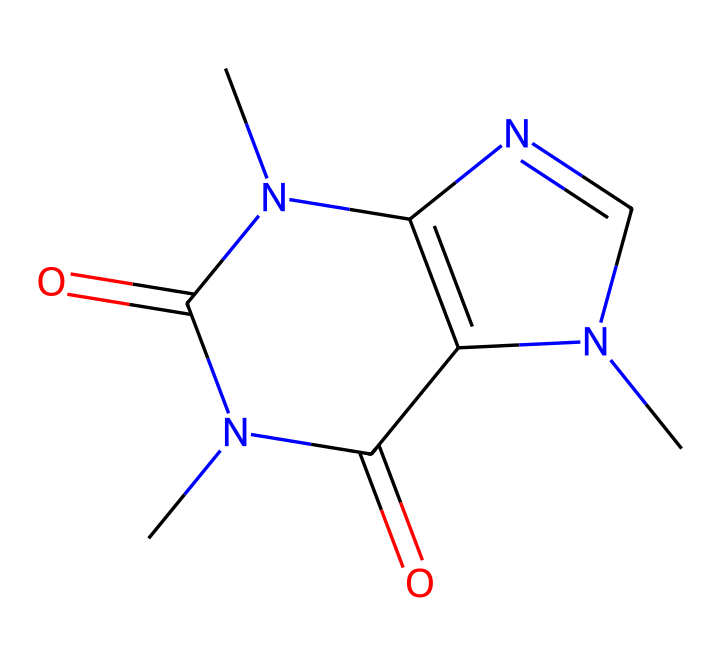how many nitrogen atoms are present in the structure? The SMILES representation indicates there are three nitrogen atoms (N), which can be identified by counting the 'N' symbols.
Answer: 3 what is the primary functional group in caffeine? The primary functional group in caffeine is the amine group, characterized by the nitrogen atoms connected to carbon atoms. This can be inferred from the presence of the N atoms in the structure.
Answer: amine what is the overall molecular formula of caffeine? By examining the structure and counting the carbon (C), hydrogen (H), nitrogen (N), and oxygen (O) atoms, the molecular formula can be determined as C8H10N4O2.
Answer: C8H10N4O2 how many rings are present in the caffeine structure? The structure of caffeine reveals two fused rings (a purine core), which can be identified by the two interlinked cyclic components in the SMILES representation.
Answer: 2 which elements are present in caffeine? The elements present in caffeine are carbon (C), hydrogen (H), nitrogen (N), and oxygen (O), as indicated by the respective letters in the SMILES representation.
Answer: carbon, hydrogen, nitrogen, oxygen how does the molecular structure of caffeine influence its stimulant properties? Caffeine's structure contains multiple nitrogen atoms in a fused ring system, which contributes to its ability to block adenosine receptors in the brain, enhancing alertness and focus. This reasoning involves understanding the relationship between structure and biological function.
Answer: promotes alertness 